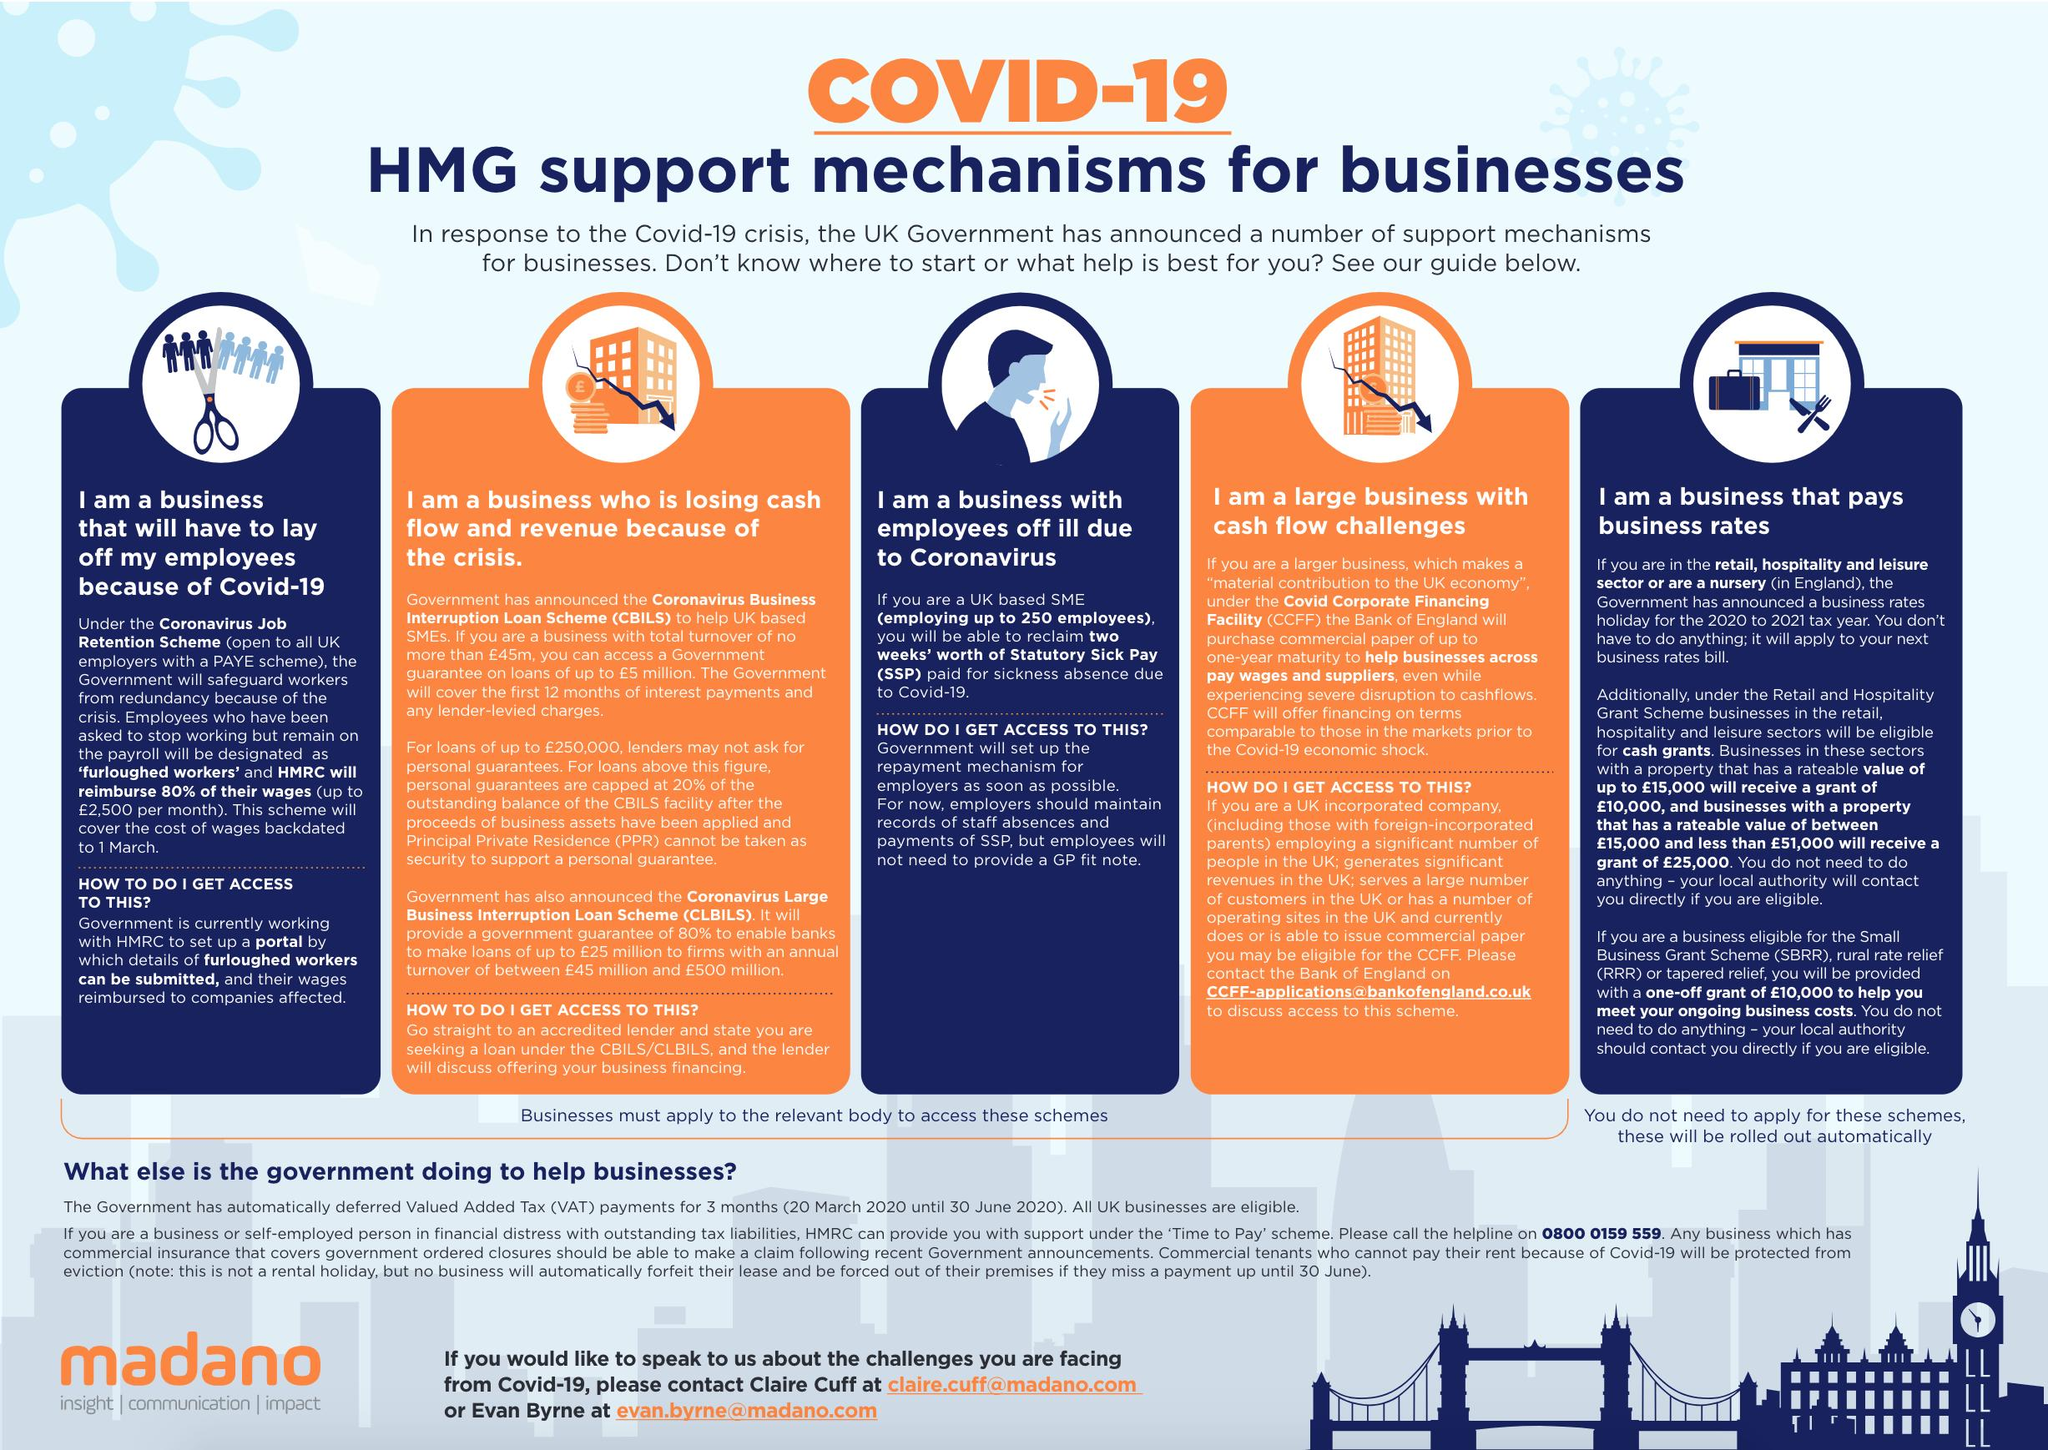Give some essential details in this illustration. The Capital for Business is For businesses of all sizes, including large businesses with cash flow challenges, such as those faced by the CCFF, which is designed to provide a solution for such businesses by providing access to the capital they need to thrive and grow, and ultimately drive economic growth. The Coronavirus job retention scheme is intended for all UK employers with a PAYE scheme. The schemes will be automatically rolled out for businesses that pay business rates. There are five types of businesses that have been considered. CBILS is designed for businesses that are experiencing a loss of cash flow and revenue as a result of the ongoing global economic crisis. 